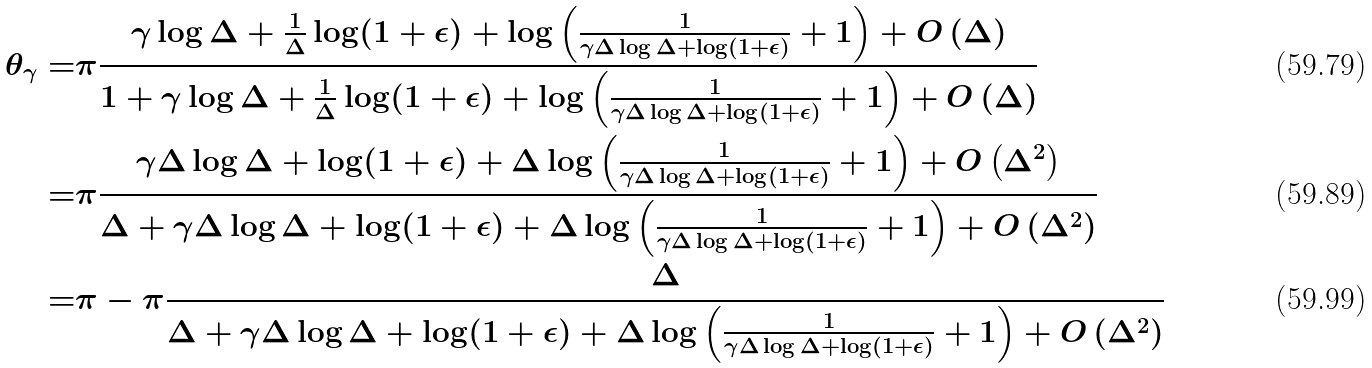Convert formula to latex. <formula><loc_0><loc_0><loc_500><loc_500>\theta _ { \gamma } = & \pi \frac { \gamma \log \Delta + \frac { 1 } { \Delta } \log ( 1 + \epsilon ) + \log \left ( \frac { 1 } { \gamma \Delta \log \Delta + \log ( 1 + \epsilon ) } + 1 \right ) + O \left ( \Delta \right ) } { 1 + \gamma \log \Delta + \frac { 1 } { \Delta } \log ( 1 + \epsilon ) + \log \left ( \frac { 1 } { \gamma \Delta \log \Delta + \log ( 1 + \epsilon ) } + 1 \right ) + O \left ( \Delta \right ) } \\ = & \pi \frac { \gamma \Delta \log \Delta + \log ( 1 + \epsilon ) + \Delta \log \left ( \frac { 1 } { \gamma \Delta \log \Delta + \log ( 1 + \epsilon ) } + 1 \right ) + O \left ( \Delta ^ { 2 } \right ) } { \Delta + \gamma \Delta \log \Delta + \log ( 1 + \epsilon ) + \Delta \log \left ( \frac { 1 } { \gamma \Delta \log \Delta + \log ( 1 + \epsilon ) } + 1 \right ) + O \left ( \Delta ^ { 2 } \right ) } \\ = & \pi - \pi \frac { \Delta } { \Delta + \gamma \Delta \log \Delta + \log ( 1 + \epsilon ) + \Delta \log \left ( \frac { 1 } { \gamma \Delta \log \Delta + \log ( 1 + \epsilon ) } + 1 \right ) + O \left ( \Delta ^ { 2 } \right ) }</formula> 